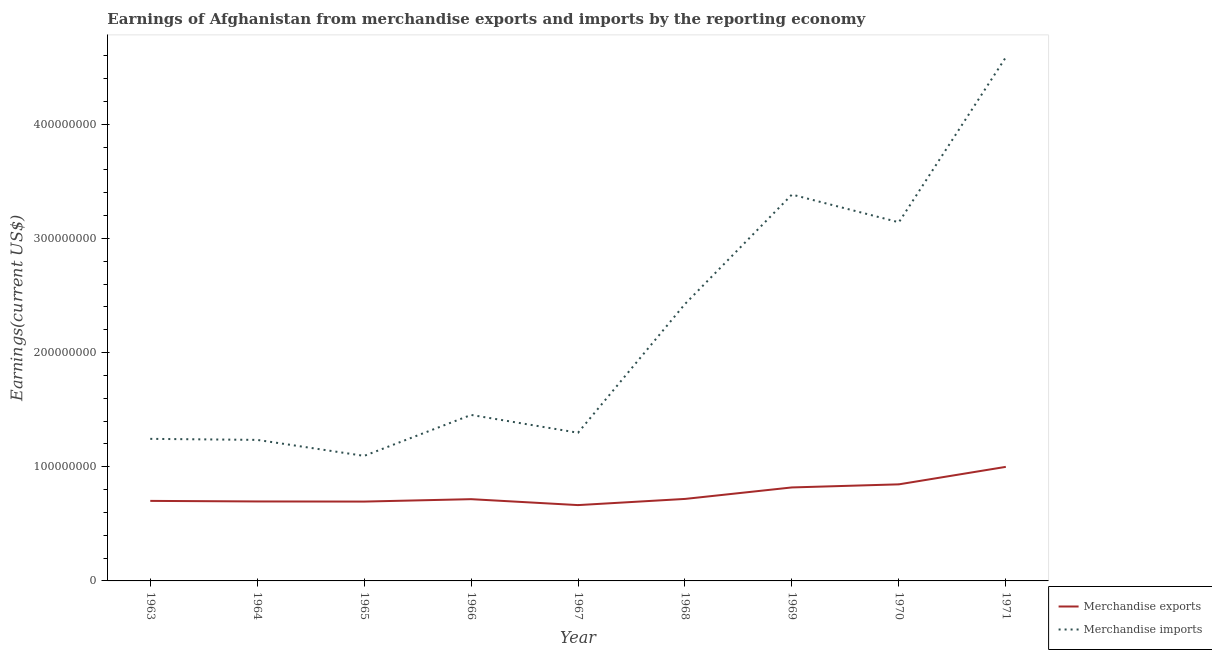Does the line corresponding to earnings from merchandise imports intersect with the line corresponding to earnings from merchandise exports?
Keep it short and to the point. No. What is the earnings from merchandise exports in 1970?
Offer a very short reply. 8.46e+07. Across all years, what is the maximum earnings from merchandise imports?
Provide a short and direct response. 4.59e+08. Across all years, what is the minimum earnings from merchandise exports?
Make the answer very short. 6.64e+07. In which year was the earnings from merchandise exports minimum?
Offer a very short reply. 1967. What is the total earnings from merchandise exports in the graph?
Provide a succinct answer. 6.85e+08. What is the difference between the earnings from merchandise imports in 1967 and that in 1970?
Your answer should be very brief. -1.84e+08. What is the difference between the earnings from merchandise imports in 1965 and the earnings from merchandise exports in 1963?
Offer a terse response. 3.94e+07. What is the average earnings from merchandise exports per year?
Provide a short and direct response. 7.62e+07. In the year 1969, what is the difference between the earnings from merchandise exports and earnings from merchandise imports?
Provide a succinct answer. -2.57e+08. In how many years, is the earnings from merchandise exports greater than 420000000 US$?
Make the answer very short. 0. What is the ratio of the earnings from merchandise exports in 1963 to that in 1969?
Provide a succinct answer. 0.86. Is the earnings from merchandise exports in 1965 less than that in 1970?
Your answer should be very brief. Yes. What is the difference between the highest and the second highest earnings from merchandise exports?
Provide a short and direct response. 1.53e+07. What is the difference between the highest and the lowest earnings from merchandise imports?
Keep it short and to the point. 3.49e+08. In how many years, is the earnings from merchandise exports greater than the average earnings from merchandise exports taken over all years?
Your answer should be very brief. 3. Does the earnings from merchandise imports monotonically increase over the years?
Give a very brief answer. No. Does the graph contain grids?
Make the answer very short. No. How are the legend labels stacked?
Ensure brevity in your answer.  Vertical. What is the title of the graph?
Provide a succinct answer. Earnings of Afghanistan from merchandise exports and imports by the reporting economy. Does "Fertility rate" appear as one of the legend labels in the graph?
Make the answer very short. No. What is the label or title of the Y-axis?
Your response must be concise. Earnings(current US$). What is the Earnings(current US$) of Merchandise exports in 1963?
Offer a terse response. 7.01e+07. What is the Earnings(current US$) in Merchandise imports in 1963?
Offer a terse response. 1.24e+08. What is the Earnings(current US$) in Merchandise exports in 1964?
Offer a terse response. 6.96e+07. What is the Earnings(current US$) in Merchandise imports in 1964?
Make the answer very short. 1.24e+08. What is the Earnings(current US$) of Merchandise exports in 1965?
Your response must be concise. 6.95e+07. What is the Earnings(current US$) in Merchandise imports in 1965?
Offer a very short reply. 1.10e+08. What is the Earnings(current US$) of Merchandise exports in 1966?
Your response must be concise. 7.16e+07. What is the Earnings(current US$) of Merchandise imports in 1966?
Provide a short and direct response. 1.45e+08. What is the Earnings(current US$) of Merchandise exports in 1967?
Ensure brevity in your answer.  6.64e+07. What is the Earnings(current US$) in Merchandise imports in 1967?
Ensure brevity in your answer.  1.30e+08. What is the Earnings(current US$) of Merchandise exports in 1968?
Ensure brevity in your answer.  7.18e+07. What is the Earnings(current US$) in Merchandise imports in 1968?
Provide a succinct answer. 2.43e+08. What is the Earnings(current US$) of Merchandise exports in 1969?
Keep it short and to the point. 8.19e+07. What is the Earnings(current US$) of Merchandise imports in 1969?
Ensure brevity in your answer.  3.38e+08. What is the Earnings(current US$) of Merchandise exports in 1970?
Your answer should be very brief. 8.46e+07. What is the Earnings(current US$) of Merchandise imports in 1970?
Provide a short and direct response. 3.14e+08. What is the Earnings(current US$) in Merchandise exports in 1971?
Your answer should be very brief. 9.99e+07. What is the Earnings(current US$) of Merchandise imports in 1971?
Keep it short and to the point. 4.59e+08. Across all years, what is the maximum Earnings(current US$) in Merchandise exports?
Your answer should be compact. 9.99e+07. Across all years, what is the maximum Earnings(current US$) in Merchandise imports?
Your response must be concise. 4.59e+08. Across all years, what is the minimum Earnings(current US$) in Merchandise exports?
Give a very brief answer. 6.64e+07. Across all years, what is the minimum Earnings(current US$) of Merchandise imports?
Provide a succinct answer. 1.10e+08. What is the total Earnings(current US$) in Merchandise exports in the graph?
Give a very brief answer. 6.85e+08. What is the total Earnings(current US$) of Merchandise imports in the graph?
Offer a very short reply. 1.99e+09. What is the difference between the Earnings(current US$) of Merchandise exports in 1963 and that in 1964?
Offer a very short reply. 5.00e+05. What is the difference between the Earnings(current US$) in Merchandise imports in 1963 and that in 1964?
Your answer should be very brief. 9.10e+05. What is the difference between the Earnings(current US$) of Merchandise imports in 1963 and that in 1965?
Keep it short and to the point. 1.49e+07. What is the difference between the Earnings(current US$) in Merchandise exports in 1963 and that in 1966?
Your response must be concise. -1.50e+06. What is the difference between the Earnings(current US$) in Merchandise imports in 1963 and that in 1966?
Offer a very short reply. -2.10e+07. What is the difference between the Earnings(current US$) of Merchandise exports in 1963 and that in 1967?
Your answer should be compact. 3.69e+06. What is the difference between the Earnings(current US$) of Merchandise imports in 1963 and that in 1967?
Your response must be concise. -5.36e+06. What is the difference between the Earnings(current US$) in Merchandise exports in 1963 and that in 1968?
Provide a succinct answer. -1.72e+06. What is the difference between the Earnings(current US$) in Merchandise imports in 1963 and that in 1968?
Your response must be concise. -1.18e+08. What is the difference between the Earnings(current US$) in Merchandise exports in 1963 and that in 1969?
Ensure brevity in your answer.  -1.18e+07. What is the difference between the Earnings(current US$) of Merchandise imports in 1963 and that in 1969?
Provide a succinct answer. -2.14e+08. What is the difference between the Earnings(current US$) of Merchandise exports in 1963 and that in 1970?
Give a very brief answer. -1.45e+07. What is the difference between the Earnings(current US$) of Merchandise imports in 1963 and that in 1970?
Ensure brevity in your answer.  -1.90e+08. What is the difference between the Earnings(current US$) in Merchandise exports in 1963 and that in 1971?
Provide a succinct answer. -2.98e+07. What is the difference between the Earnings(current US$) of Merchandise imports in 1963 and that in 1971?
Offer a very short reply. -3.34e+08. What is the difference between the Earnings(current US$) of Merchandise exports in 1964 and that in 1965?
Keep it short and to the point. 1.00e+05. What is the difference between the Earnings(current US$) in Merchandise imports in 1964 and that in 1965?
Keep it short and to the point. 1.40e+07. What is the difference between the Earnings(current US$) of Merchandise imports in 1964 and that in 1966?
Keep it short and to the point. -2.19e+07. What is the difference between the Earnings(current US$) in Merchandise exports in 1964 and that in 1967?
Offer a terse response. 3.19e+06. What is the difference between the Earnings(current US$) in Merchandise imports in 1964 and that in 1967?
Provide a succinct answer. -6.27e+06. What is the difference between the Earnings(current US$) of Merchandise exports in 1964 and that in 1968?
Keep it short and to the point. -2.22e+06. What is the difference between the Earnings(current US$) in Merchandise imports in 1964 and that in 1968?
Ensure brevity in your answer.  -1.19e+08. What is the difference between the Earnings(current US$) in Merchandise exports in 1964 and that in 1969?
Provide a succinct answer. -1.23e+07. What is the difference between the Earnings(current US$) in Merchandise imports in 1964 and that in 1969?
Make the answer very short. -2.15e+08. What is the difference between the Earnings(current US$) in Merchandise exports in 1964 and that in 1970?
Your answer should be very brief. -1.50e+07. What is the difference between the Earnings(current US$) in Merchandise imports in 1964 and that in 1970?
Offer a terse response. -1.91e+08. What is the difference between the Earnings(current US$) in Merchandise exports in 1964 and that in 1971?
Offer a very short reply. -3.03e+07. What is the difference between the Earnings(current US$) of Merchandise imports in 1964 and that in 1971?
Your answer should be very brief. -3.35e+08. What is the difference between the Earnings(current US$) of Merchandise exports in 1965 and that in 1966?
Ensure brevity in your answer.  -2.10e+06. What is the difference between the Earnings(current US$) in Merchandise imports in 1965 and that in 1966?
Provide a short and direct response. -3.59e+07. What is the difference between the Earnings(current US$) of Merchandise exports in 1965 and that in 1967?
Your response must be concise. 3.09e+06. What is the difference between the Earnings(current US$) of Merchandise imports in 1965 and that in 1967?
Your answer should be very brief. -2.03e+07. What is the difference between the Earnings(current US$) in Merchandise exports in 1965 and that in 1968?
Provide a succinct answer. -2.32e+06. What is the difference between the Earnings(current US$) of Merchandise imports in 1965 and that in 1968?
Provide a succinct answer. -1.33e+08. What is the difference between the Earnings(current US$) of Merchandise exports in 1965 and that in 1969?
Provide a succinct answer. -1.24e+07. What is the difference between the Earnings(current US$) of Merchandise imports in 1965 and that in 1969?
Keep it short and to the point. -2.29e+08. What is the difference between the Earnings(current US$) in Merchandise exports in 1965 and that in 1970?
Provide a succinct answer. -1.51e+07. What is the difference between the Earnings(current US$) in Merchandise imports in 1965 and that in 1970?
Give a very brief answer. -2.05e+08. What is the difference between the Earnings(current US$) in Merchandise exports in 1965 and that in 1971?
Provide a short and direct response. -3.04e+07. What is the difference between the Earnings(current US$) in Merchandise imports in 1965 and that in 1971?
Your answer should be compact. -3.49e+08. What is the difference between the Earnings(current US$) of Merchandise exports in 1966 and that in 1967?
Your answer should be compact. 5.19e+06. What is the difference between the Earnings(current US$) of Merchandise imports in 1966 and that in 1967?
Provide a short and direct response. 1.56e+07. What is the difference between the Earnings(current US$) of Merchandise exports in 1966 and that in 1968?
Keep it short and to the point. -2.17e+05. What is the difference between the Earnings(current US$) in Merchandise imports in 1966 and that in 1968?
Your answer should be compact. -9.71e+07. What is the difference between the Earnings(current US$) in Merchandise exports in 1966 and that in 1969?
Offer a terse response. -1.03e+07. What is the difference between the Earnings(current US$) of Merchandise imports in 1966 and that in 1969?
Provide a succinct answer. -1.93e+08. What is the difference between the Earnings(current US$) in Merchandise exports in 1966 and that in 1970?
Keep it short and to the point. -1.30e+07. What is the difference between the Earnings(current US$) in Merchandise imports in 1966 and that in 1970?
Keep it short and to the point. -1.69e+08. What is the difference between the Earnings(current US$) in Merchandise exports in 1966 and that in 1971?
Keep it short and to the point. -2.83e+07. What is the difference between the Earnings(current US$) in Merchandise imports in 1966 and that in 1971?
Provide a short and direct response. -3.13e+08. What is the difference between the Earnings(current US$) of Merchandise exports in 1967 and that in 1968?
Give a very brief answer. -5.41e+06. What is the difference between the Earnings(current US$) in Merchandise imports in 1967 and that in 1968?
Your answer should be compact. -1.13e+08. What is the difference between the Earnings(current US$) of Merchandise exports in 1967 and that in 1969?
Keep it short and to the point. -1.55e+07. What is the difference between the Earnings(current US$) in Merchandise imports in 1967 and that in 1969?
Provide a short and direct response. -2.09e+08. What is the difference between the Earnings(current US$) in Merchandise exports in 1967 and that in 1970?
Make the answer very short. -1.82e+07. What is the difference between the Earnings(current US$) in Merchandise imports in 1967 and that in 1970?
Ensure brevity in your answer.  -1.84e+08. What is the difference between the Earnings(current US$) in Merchandise exports in 1967 and that in 1971?
Make the answer very short. -3.35e+07. What is the difference between the Earnings(current US$) in Merchandise imports in 1967 and that in 1971?
Your response must be concise. -3.29e+08. What is the difference between the Earnings(current US$) in Merchandise exports in 1968 and that in 1969?
Give a very brief answer. -1.01e+07. What is the difference between the Earnings(current US$) of Merchandise imports in 1968 and that in 1969?
Offer a very short reply. -9.59e+07. What is the difference between the Earnings(current US$) in Merchandise exports in 1968 and that in 1970?
Ensure brevity in your answer.  -1.28e+07. What is the difference between the Earnings(current US$) of Merchandise imports in 1968 and that in 1970?
Offer a very short reply. -7.16e+07. What is the difference between the Earnings(current US$) in Merchandise exports in 1968 and that in 1971?
Offer a terse response. -2.81e+07. What is the difference between the Earnings(current US$) of Merchandise imports in 1968 and that in 1971?
Keep it short and to the point. -2.16e+08. What is the difference between the Earnings(current US$) in Merchandise exports in 1969 and that in 1970?
Make the answer very short. -2.71e+06. What is the difference between the Earnings(current US$) of Merchandise imports in 1969 and that in 1970?
Your answer should be compact. 2.43e+07. What is the difference between the Earnings(current US$) of Merchandise exports in 1969 and that in 1971?
Offer a very short reply. -1.80e+07. What is the difference between the Earnings(current US$) of Merchandise imports in 1969 and that in 1971?
Give a very brief answer. -1.20e+08. What is the difference between the Earnings(current US$) of Merchandise exports in 1970 and that in 1971?
Your answer should be very brief. -1.53e+07. What is the difference between the Earnings(current US$) of Merchandise imports in 1970 and that in 1971?
Your answer should be very brief. -1.45e+08. What is the difference between the Earnings(current US$) of Merchandise exports in 1963 and the Earnings(current US$) of Merchandise imports in 1964?
Make the answer very short. -5.34e+07. What is the difference between the Earnings(current US$) of Merchandise exports in 1963 and the Earnings(current US$) of Merchandise imports in 1965?
Provide a succinct answer. -3.94e+07. What is the difference between the Earnings(current US$) in Merchandise exports in 1963 and the Earnings(current US$) in Merchandise imports in 1966?
Provide a succinct answer. -7.53e+07. What is the difference between the Earnings(current US$) of Merchandise exports in 1963 and the Earnings(current US$) of Merchandise imports in 1967?
Ensure brevity in your answer.  -5.97e+07. What is the difference between the Earnings(current US$) in Merchandise exports in 1963 and the Earnings(current US$) in Merchandise imports in 1968?
Offer a very short reply. -1.72e+08. What is the difference between the Earnings(current US$) in Merchandise exports in 1963 and the Earnings(current US$) in Merchandise imports in 1969?
Your answer should be very brief. -2.68e+08. What is the difference between the Earnings(current US$) of Merchandise exports in 1963 and the Earnings(current US$) of Merchandise imports in 1970?
Provide a short and direct response. -2.44e+08. What is the difference between the Earnings(current US$) in Merchandise exports in 1963 and the Earnings(current US$) in Merchandise imports in 1971?
Make the answer very short. -3.89e+08. What is the difference between the Earnings(current US$) of Merchandise exports in 1964 and the Earnings(current US$) of Merchandise imports in 1965?
Your answer should be compact. -3.99e+07. What is the difference between the Earnings(current US$) in Merchandise exports in 1964 and the Earnings(current US$) in Merchandise imports in 1966?
Make the answer very short. -7.58e+07. What is the difference between the Earnings(current US$) of Merchandise exports in 1964 and the Earnings(current US$) of Merchandise imports in 1967?
Your response must be concise. -6.02e+07. What is the difference between the Earnings(current US$) of Merchandise exports in 1964 and the Earnings(current US$) of Merchandise imports in 1968?
Provide a short and direct response. -1.73e+08. What is the difference between the Earnings(current US$) in Merchandise exports in 1964 and the Earnings(current US$) in Merchandise imports in 1969?
Give a very brief answer. -2.69e+08. What is the difference between the Earnings(current US$) in Merchandise exports in 1964 and the Earnings(current US$) in Merchandise imports in 1970?
Provide a short and direct response. -2.45e+08. What is the difference between the Earnings(current US$) of Merchandise exports in 1964 and the Earnings(current US$) of Merchandise imports in 1971?
Make the answer very short. -3.89e+08. What is the difference between the Earnings(current US$) in Merchandise exports in 1965 and the Earnings(current US$) in Merchandise imports in 1966?
Provide a succinct answer. -7.59e+07. What is the difference between the Earnings(current US$) of Merchandise exports in 1965 and the Earnings(current US$) of Merchandise imports in 1967?
Your response must be concise. -6.03e+07. What is the difference between the Earnings(current US$) in Merchandise exports in 1965 and the Earnings(current US$) in Merchandise imports in 1968?
Your answer should be very brief. -1.73e+08. What is the difference between the Earnings(current US$) in Merchandise exports in 1965 and the Earnings(current US$) in Merchandise imports in 1969?
Provide a succinct answer. -2.69e+08. What is the difference between the Earnings(current US$) in Merchandise exports in 1965 and the Earnings(current US$) in Merchandise imports in 1970?
Your answer should be compact. -2.45e+08. What is the difference between the Earnings(current US$) of Merchandise exports in 1965 and the Earnings(current US$) of Merchandise imports in 1971?
Your answer should be compact. -3.89e+08. What is the difference between the Earnings(current US$) of Merchandise exports in 1966 and the Earnings(current US$) of Merchandise imports in 1967?
Give a very brief answer. -5.82e+07. What is the difference between the Earnings(current US$) of Merchandise exports in 1966 and the Earnings(current US$) of Merchandise imports in 1968?
Provide a short and direct response. -1.71e+08. What is the difference between the Earnings(current US$) of Merchandise exports in 1966 and the Earnings(current US$) of Merchandise imports in 1969?
Your response must be concise. -2.67e+08. What is the difference between the Earnings(current US$) in Merchandise exports in 1966 and the Earnings(current US$) in Merchandise imports in 1970?
Provide a succinct answer. -2.43e+08. What is the difference between the Earnings(current US$) in Merchandise exports in 1966 and the Earnings(current US$) in Merchandise imports in 1971?
Provide a succinct answer. -3.87e+08. What is the difference between the Earnings(current US$) of Merchandise exports in 1967 and the Earnings(current US$) of Merchandise imports in 1968?
Provide a succinct answer. -1.76e+08. What is the difference between the Earnings(current US$) in Merchandise exports in 1967 and the Earnings(current US$) in Merchandise imports in 1969?
Give a very brief answer. -2.72e+08. What is the difference between the Earnings(current US$) of Merchandise exports in 1967 and the Earnings(current US$) of Merchandise imports in 1970?
Make the answer very short. -2.48e+08. What is the difference between the Earnings(current US$) in Merchandise exports in 1967 and the Earnings(current US$) in Merchandise imports in 1971?
Offer a terse response. -3.92e+08. What is the difference between the Earnings(current US$) in Merchandise exports in 1968 and the Earnings(current US$) in Merchandise imports in 1969?
Provide a short and direct response. -2.67e+08. What is the difference between the Earnings(current US$) of Merchandise exports in 1968 and the Earnings(current US$) of Merchandise imports in 1970?
Provide a succinct answer. -2.42e+08. What is the difference between the Earnings(current US$) of Merchandise exports in 1968 and the Earnings(current US$) of Merchandise imports in 1971?
Make the answer very short. -3.87e+08. What is the difference between the Earnings(current US$) in Merchandise exports in 1969 and the Earnings(current US$) in Merchandise imports in 1970?
Give a very brief answer. -2.32e+08. What is the difference between the Earnings(current US$) of Merchandise exports in 1969 and the Earnings(current US$) of Merchandise imports in 1971?
Offer a very short reply. -3.77e+08. What is the difference between the Earnings(current US$) of Merchandise exports in 1970 and the Earnings(current US$) of Merchandise imports in 1971?
Keep it short and to the point. -3.74e+08. What is the average Earnings(current US$) in Merchandise exports per year?
Keep it short and to the point. 7.62e+07. What is the average Earnings(current US$) of Merchandise imports per year?
Your answer should be compact. 2.21e+08. In the year 1963, what is the difference between the Earnings(current US$) of Merchandise exports and Earnings(current US$) of Merchandise imports?
Your response must be concise. -5.43e+07. In the year 1964, what is the difference between the Earnings(current US$) of Merchandise exports and Earnings(current US$) of Merchandise imports?
Provide a short and direct response. -5.39e+07. In the year 1965, what is the difference between the Earnings(current US$) in Merchandise exports and Earnings(current US$) in Merchandise imports?
Keep it short and to the point. -4.00e+07. In the year 1966, what is the difference between the Earnings(current US$) in Merchandise exports and Earnings(current US$) in Merchandise imports?
Offer a very short reply. -7.38e+07. In the year 1967, what is the difference between the Earnings(current US$) of Merchandise exports and Earnings(current US$) of Merchandise imports?
Offer a terse response. -6.34e+07. In the year 1968, what is the difference between the Earnings(current US$) in Merchandise exports and Earnings(current US$) in Merchandise imports?
Ensure brevity in your answer.  -1.71e+08. In the year 1969, what is the difference between the Earnings(current US$) in Merchandise exports and Earnings(current US$) in Merchandise imports?
Make the answer very short. -2.57e+08. In the year 1970, what is the difference between the Earnings(current US$) in Merchandise exports and Earnings(current US$) in Merchandise imports?
Offer a very short reply. -2.30e+08. In the year 1971, what is the difference between the Earnings(current US$) in Merchandise exports and Earnings(current US$) in Merchandise imports?
Keep it short and to the point. -3.59e+08. What is the ratio of the Earnings(current US$) in Merchandise exports in 1963 to that in 1964?
Provide a short and direct response. 1.01. What is the ratio of the Earnings(current US$) of Merchandise imports in 1963 to that in 1964?
Your answer should be very brief. 1.01. What is the ratio of the Earnings(current US$) of Merchandise exports in 1963 to that in 1965?
Keep it short and to the point. 1.01. What is the ratio of the Earnings(current US$) in Merchandise imports in 1963 to that in 1965?
Keep it short and to the point. 1.14. What is the ratio of the Earnings(current US$) in Merchandise exports in 1963 to that in 1966?
Keep it short and to the point. 0.98. What is the ratio of the Earnings(current US$) of Merchandise imports in 1963 to that in 1966?
Ensure brevity in your answer.  0.86. What is the ratio of the Earnings(current US$) of Merchandise exports in 1963 to that in 1967?
Your answer should be compact. 1.06. What is the ratio of the Earnings(current US$) in Merchandise imports in 1963 to that in 1967?
Your response must be concise. 0.96. What is the ratio of the Earnings(current US$) in Merchandise exports in 1963 to that in 1968?
Offer a terse response. 0.98. What is the ratio of the Earnings(current US$) of Merchandise imports in 1963 to that in 1968?
Provide a short and direct response. 0.51. What is the ratio of the Earnings(current US$) of Merchandise exports in 1963 to that in 1969?
Your answer should be very brief. 0.86. What is the ratio of the Earnings(current US$) of Merchandise imports in 1963 to that in 1969?
Keep it short and to the point. 0.37. What is the ratio of the Earnings(current US$) of Merchandise exports in 1963 to that in 1970?
Your answer should be compact. 0.83. What is the ratio of the Earnings(current US$) of Merchandise imports in 1963 to that in 1970?
Provide a short and direct response. 0.4. What is the ratio of the Earnings(current US$) in Merchandise exports in 1963 to that in 1971?
Offer a terse response. 0.7. What is the ratio of the Earnings(current US$) in Merchandise imports in 1963 to that in 1971?
Keep it short and to the point. 0.27. What is the ratio of the Earnings(current US$) in Merchandise imports in 1964 to that in 1965?
Ensure brevity in your answer.  1.13. What is the ratio of the Earnings(current US$) of Merchandise exports in 1964 to that in 1966?
Ensure brevity in your answer.  0.97. What is the ratio of the Earnings(current US$) of Merchandise imports in 1964 to that in 1966?
Make the answer very short. 0.85. What is the ratio of the Earnings(current US$) in Merchandise exports in 1964 to that in 1967?
Offer a very short reply. 1.05. What is the ratio of the Earnings(current US$) of Merchandise imports in 1964 to that in 1967?
Make the answer very short. 0.95. What is the ratio of the Earnings(current US$) in Merchandise exports in 1964 to that in 1968?
Your answer should be compact. 0.97. What is the ratio of the Earnings(current US$) in Merchandise imports in 1964 to that in 1968?
Keep it short and to the point. 0.51. What is the ratio of the Earnings(current US$) of Merchandise imports in 1964 to that in 1969?
Offer a very short reply. 0.36. What is the ratio of the Earnings(current US$) in Merchandise exports in 1964 to that in 1970?
Ensure brevity in your answer.  0.82. What is the ratio of the Earnings(current US$) of Merchandise imports in 1964 to that in 1970?
Make the answer very short. 0.39. What is the ratio of the Earnings(current US$) of Merchandise exports in 1964 to that in 1971?
Make the answer very short. 0.7. What is the ratio of the Earnings(current US$) of Merchandise imports in 1964 to that in 1971?
Make the answer very short. 0.27. What is the ratio of the Earnings(current US$) in Merchandise exports in 1965 to that in 1966?
Your answer should be very brief. 0.97. What is the ratio of the Earnings(current US$) of Merchandise imports in 1965 to that in 1966?
Make the answer very short. 0.75. What is the ratio of the Earnings(current US$) of Merchandise exports in 1965 to that in 1967?
Give a very brief answer. 1.05. What is the ratio of the Earnings(current US$) of Merchandise imports in 1965 to that in 1967?
Give a very brief answer. 0.84. What is the ratio of the Earnings(current US$) of Merchandise exports in 1965 to that in 1968?
Give a very brief answer. 0.97. What is the ratio of the Earnings(current US$) of Merchandise imports in 1965 to that in 1968?
Offer a very short reply. 0.45. What is the ratio of the Earnings(current US$) of Merchandise exports in 1965 to that in 1969?
Ensure brevity in your answer.  0.85. What is the ratio of the Earnings(current US$) in Merchandise imports in 1965 to that in 1969?
Provide a succinct answer. 0.32. What is the ratio of the Earnings(current US$) of Merchandise exports in 1965 to that in 1970?
Keep it short and to the point. 0.82. What is the ratio of the Earnings(current US$) in Merchandise imports in 1965 to that in 1970?
Offer a very short reply. 0.35. What is the ratio of the Earnings(current US$) in Merchandise exports in 1965 to that in 1971?
Ensure brevity in your answer.  0.7. What is the ratio of the Earnings(current US$) of Merchandise imports in 1965 to that in 1971?
Provide a short and direct response. 0.24. What is the ratio of the Earnings(current US$) in Merchandise exports in 1966 to that in 1967?
Your response must be concise. 1.08. What is the ratio of the Earnings(current US$) of Merchandise imports in 1966 to that in 1967?
Your answer should be compact. 1.12. What is the ratio of the Earnings(current US$) in Merchandise exports in 1966 to that in 1968?
Offer a very short reply. 1. What is the ratio of the Earnings(current US$) in Merchandise imports in 1966 to that in 1968?
Provide a short and direct response. 0.6. What is the ratio of the Earnings(current US$) of Merchandise exports in 1966 to that in 1969?
Your answer should be compact. 0.87. What is the ratio of the Earnings(current US$) in Merchandise imports in 1966 to that in 1969?
Offer a terse response. 0.43. What is the ratio of the Earnings(current US$) of Merchandise exports in 1966 to that in 1970?
Your answer should be very brief. 0.85. What is the ratio of the Earnings(current US$) of Merchandise imports in 1966 to that in 1970?
Make the answer very short. 0.46. What is the ratio of the Earnings(current US$) in Merchandise exports in 1966 to that in 1971?
Offer a very short reply. 0.72. What is the ratio of the Earnings(current US$) of Merchandise imports in 1966 to that in 1971?
Your answer should be compact. 0.32. What is the ratio of the Earnings(current US$) in Merchandise exports in 1967 to that in 1968?
Give a very brief answer. 0.92. What is the ratio of the Earnings(current US$) in Merchandise imports in 1967 to that in 1968?
Give a very brief answer. 0.54. What is the ratio of the Earnings(current US$) in Merchandise exports in 1967 to that in 1969?
Keep it short and to the point. 0.81. What is the ratio of the Earnings(current US$) of Merchandise imports in 1967 to that in 1969?
Your answer should be compact. 0.38. What is the ratio of the Earnings(current US$) in Merchandise exports in 1967 to that in 1970?
Offer a very short reply. 0.79. What is the ratio of the Earnings(current US$) in Merchandise imports in 1967 to that in 1970?
Keep it short and to the point. 0.41. What is the ratio of the Earnings(current US$) in Merchandise exports in 1967 to that in 1971?
Make the answer very short. 0.66. What is the ratio of the Earnings(current US$) in Merchandise imports in 1967 to that in 1971?
Keep it short and to the point. 0.28. What is the ratio of the Earnings(current US$) of Merchandise exports in 1968 to that in 1969?
Your answer should be compact. 0.88. What is the ratio of the Earnings(current US$) in Merchandise imports in 1968 to that in 1969?
Your answer should be compact. 0.72. What is the ratio of the Earnings(current US$) of Merchandise exports in 1968 to that in 1970?
Your answer should be compact. 0.85. What is the ratio of the Earnings(current US$) in Merchandise imports in 1968 to that in 1970?
Keep it short and to the point. 0.77. What is the ratio of the Earnings(current US$) of Merchandise exports in 1968 to that in 1971?
Offer a very short reply. 0.72. What is the ratio of the Earnings(current US$) of Merchandise imports in 1968 to that in 1971?
Your response must be concise. 0.53. What is the ratio of the Earnings(current US$) in Merchandise exports in 1969 to that in 1970?
Ensure brevity in your answer.  0.97. What is the ratio of the Earnings(current US$) of Merchandise imports in 1969 to that in 1970?
Give a very brief answer. 1.08. What is the ratio of the Earnings(current US$) in Merchandise exports in 1969 to that in 1971?
Your answer should be compact. 0.82. What is the ratio of the Earnings(current US$) of Merchandise imports in 1969 to that in 1971?
Give a very brief answer. 0.74. What is the ratio of the Earnings(current US$) in Merchandise exports in 1970 to that in 1971?
Your response must be concise. 0.85. What is the ratio of the Earnings(current US$) in Merchandise imports in 1970 to that in 1971?
Your response must be concise. 0.68. What is the difference between the highest and the second highest Earnings(current US$) of Merchandise exports?
Provide a succinct answer. 1.53e+07. What is the difference between the highest and the second highest Earnings(current US$) in Merchandise imports?
Provide a short and direct response. 1.20e+08. What is the difference between the highest and the lowest Earnings(current US$) of Merchandise exports?
Ensure brevity in your answer.  3.35e+07. What is the difference between the highest and the lowest Earnings(current US$) of Merchandise imports?
Offer a terse response. 3.49e+08. 